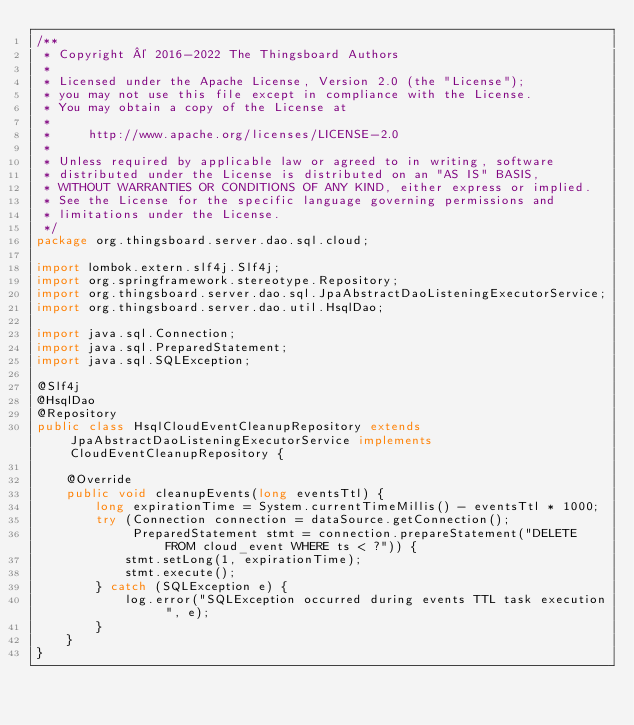Convert code to text. <code><loc_0><loc_0><loc_500><loc_500><_Java_>/**
 * Copyright © 2016-2022 The Thingsboard Authors
 *
 * Licensed under the Apache License, Version 2.0 (the "License");
 * you may not use this file except in compliance with the License.
 * You may obtain a copy of the License at
 *
 *     http://www.apache.org/licenses/LICENSE-2.0
 *
 * Unless required by applicable law or agreed to in writing, software
 * distributed under the License is distributed on an "AS IS" BASIS,
 * WITHOUT WARRANTIES OR CONDITIONS OF ANY KIND, either express or implied.
 * See the License for the specific language governing permissions and
 * limitations under the License.
 */
package org.thingsboard.server.dao.sql.cloud;

import lombok.extern.slf4j.Slf4j;
import org.springframework.stereotype.Repository;
import org.thingsboard.server.dao.sql.JpaAbstractDaoListeningExecutorService;
import org.thingsboard.server.dao.util.HsqlDao;

import java.sql.Connection;
import java.sql.PreparedStatement;
import java.sql.SQLException;

@Slf4j
@HsqlDao
@Repository
public class HsqlCloudEventCleanupRepository extends JpaAbstractDaoListeningExecutorService implements CloudEventCleanupRepository {

    @Override
    public void cleanupEvents(long eventsTtl) {
        long expirationTime = System.currentTimeMillis() - eventsTtl * 1000;
        try (Connection connection = dataSource.getConnection();
             PreparedStatement stmt = connection.prepareStatement("DELETE FROM cloud_event WHERE ts < ?")) {
            stmt.setLong(1, expirationTime);
            stmt.execute();
        } catch (SQLException e) {
            log.error("SQLException occurred during events TTL task execution ", e);
        }
    }
}
</code> 